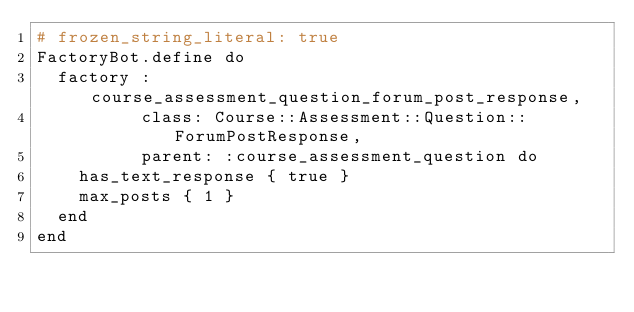<code> <loc_0><loc_0><loc_500><loc_500><_Ruby_># frozen_string_literal: true
FactoryBot.define do
  factory :course_assessment_question_forum_post_response,
          class: Course::Assessment::Question::ForumPostResponse,
          parent: :course_assessment_question do
    has_text_response { true }
    max_posts { 1 }
  end
end
</code> 